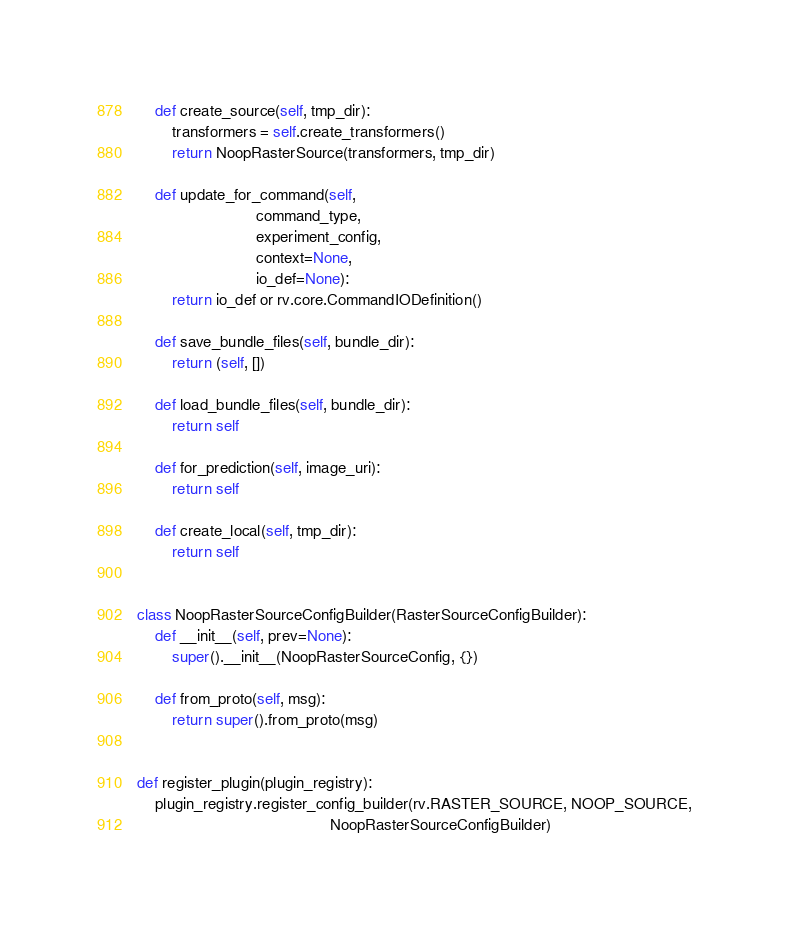<code> <loc_0><loc_0><loc_500><loc_500><_Python_>    def create_source(self, tmp_dir):
        transformers = self.create_transformers()
        return NoopRasterSource(transformers, tmp_dir)

    def update_for_command(self,
                           command_type,
                           experiment_config,
                           context=None,
                           io_def=None):
        return io_def or rv.core.CommandIODefinition()

    def save_bundle_files(self, bundle_dir):
        return (self, [])

    def load_bundle_files(self, bundle_dir):
        return self

    def for_prediction(self, image_uri):
        return self

    def create_local(self, tmp_dir):
        return self


class NoopRasterSourceConfigBuilder(RasterSourceConfigBuilder):
    def __init__(self, prev=None):
        super().__init__(NoopRasterSourceConfig, {})

    def from_proto(self, msg):
        return super().from_proto(msg)


def register_plugin(plugin_registry):
    plugin_registry.register_config_builder(rv.RASTER_SOURCE, NOOP_SOURCE,
                                            NoopRasterSourceConfigBuilder)
</code> 